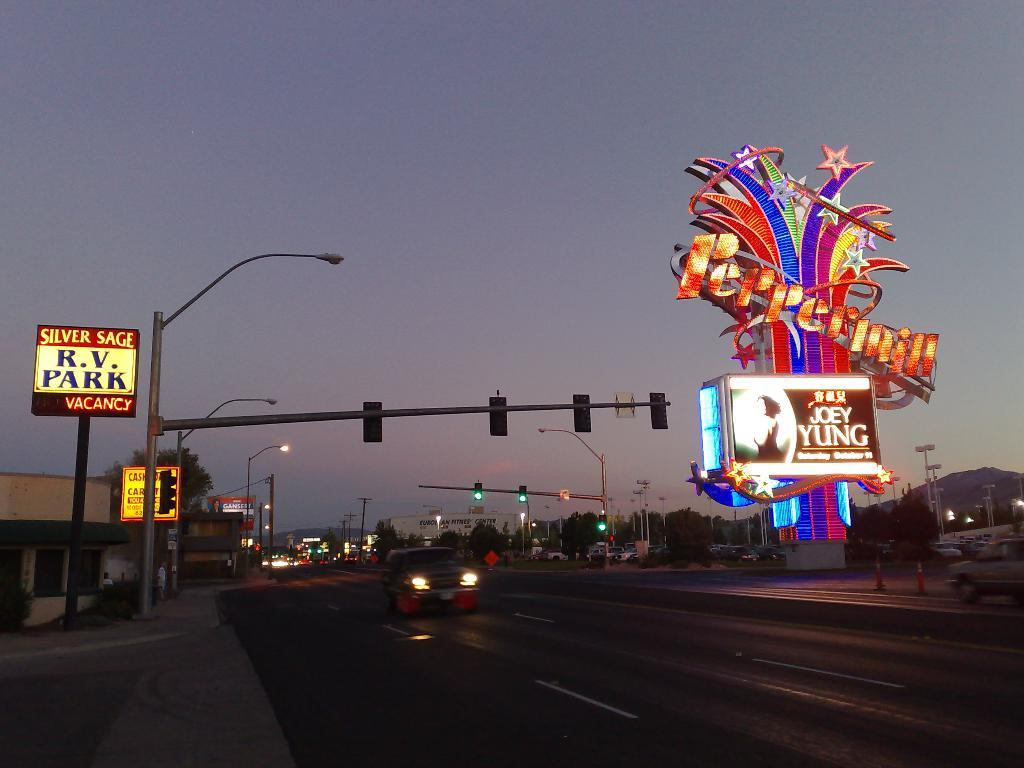<image>
Relay a brief, clear account of the picture shown. A sign reading RV Park next to a Peppermill sign. 